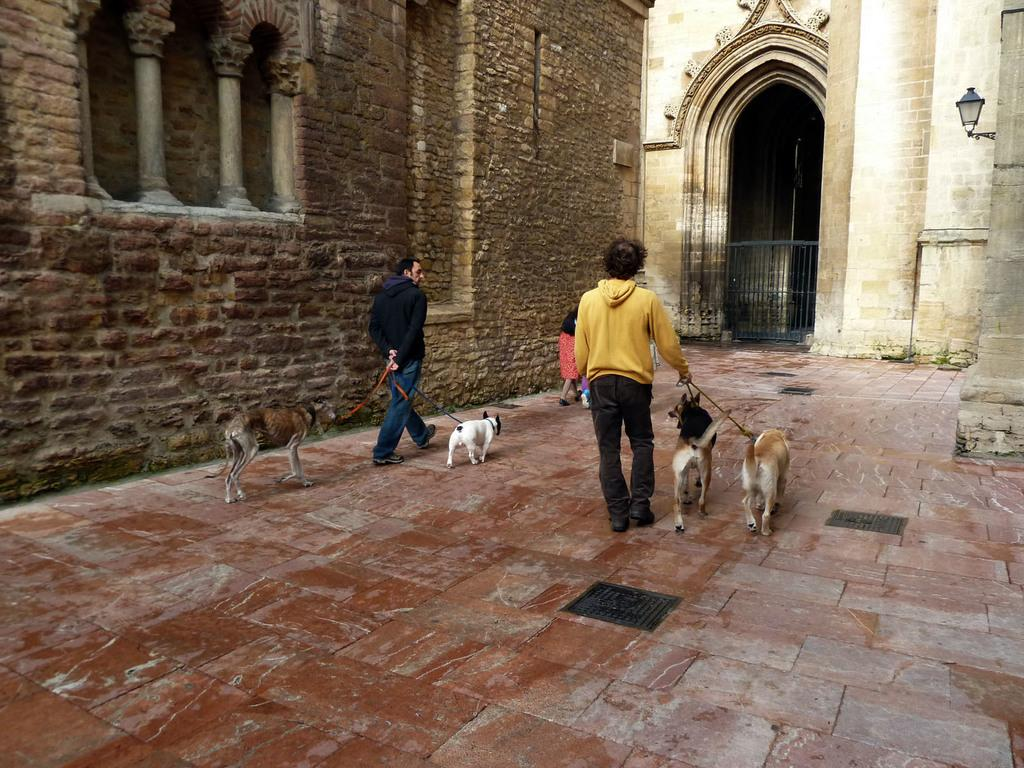What structure is present in the image? There is a building in the image. Who is in the image besides the building? There are two men in the image. What are the men holding in the image? The men are holding dogs. How are the dogs connected to the men? The dogs are connected to the men with a string. What type of scarecrow can be seen in the image? There is no scarecrow present in the image. Can you tell me how the men are planning their trip in the image? There is no indication of a trip or any planning in the image; it simply shows two men holding dogs connected by a string. 